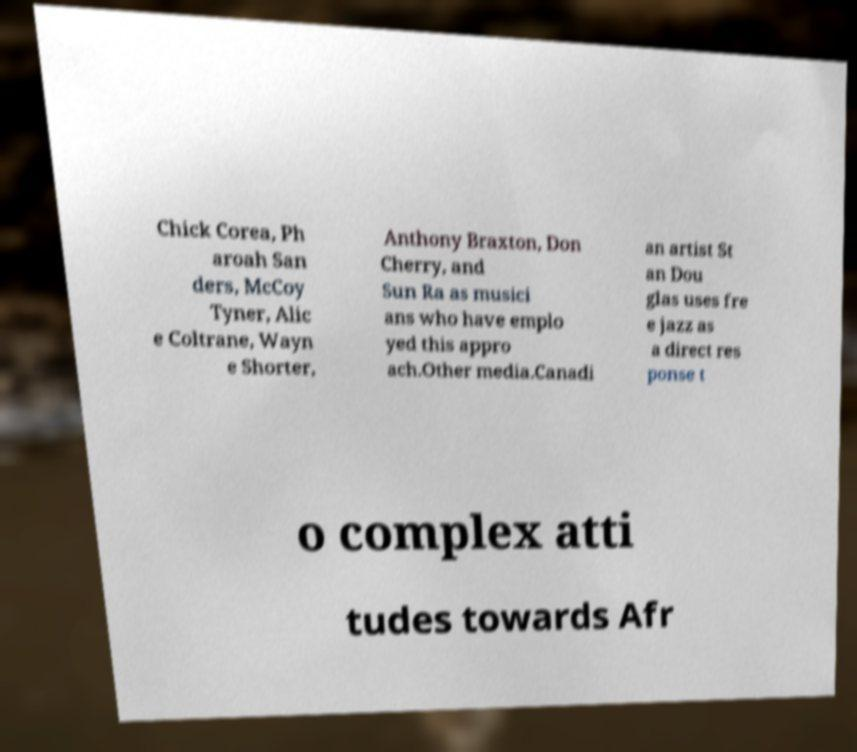Could you extract and type out the text from this image? Chick Corea, Ph aroah San ders, McCoy Tyner, Alic e Coltrane, Wayn e Shorter, Anthony Braxton, Don Cherry, and Sun Ra as musici ans who have emplo yed this appro ach.Other media.Canadi an artist St an Dou glas uses fre e jazz as a direct res ponse t o complex atti tudes towards Afr 